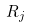Convert formula to latex. <formula><loc_0><loc_0><loc_500><loc_500>R _ { j }</formula> 